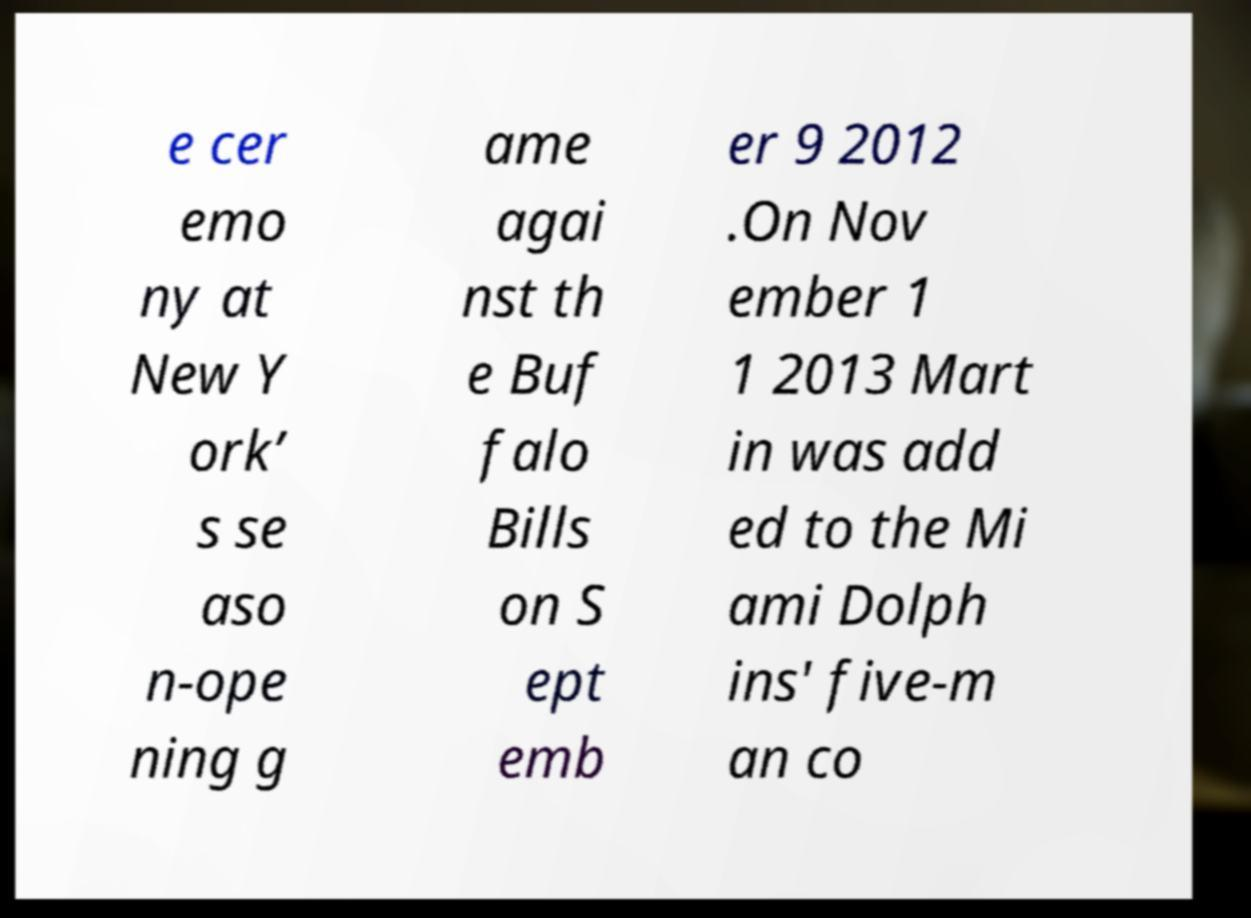Can you read and provide the text displayed in the image?This photo seems to have some interesting text. Can you extract and type it out for me? e cer emo ny at New Y ork’ s se aso n-ope ning g ame agai nst th e Buf falo Bills on S ept emb er 9 2012 .On Nov ember 1 1 2013 Mart in was add ed to the Mi ami Dolph ins' five-m an co 